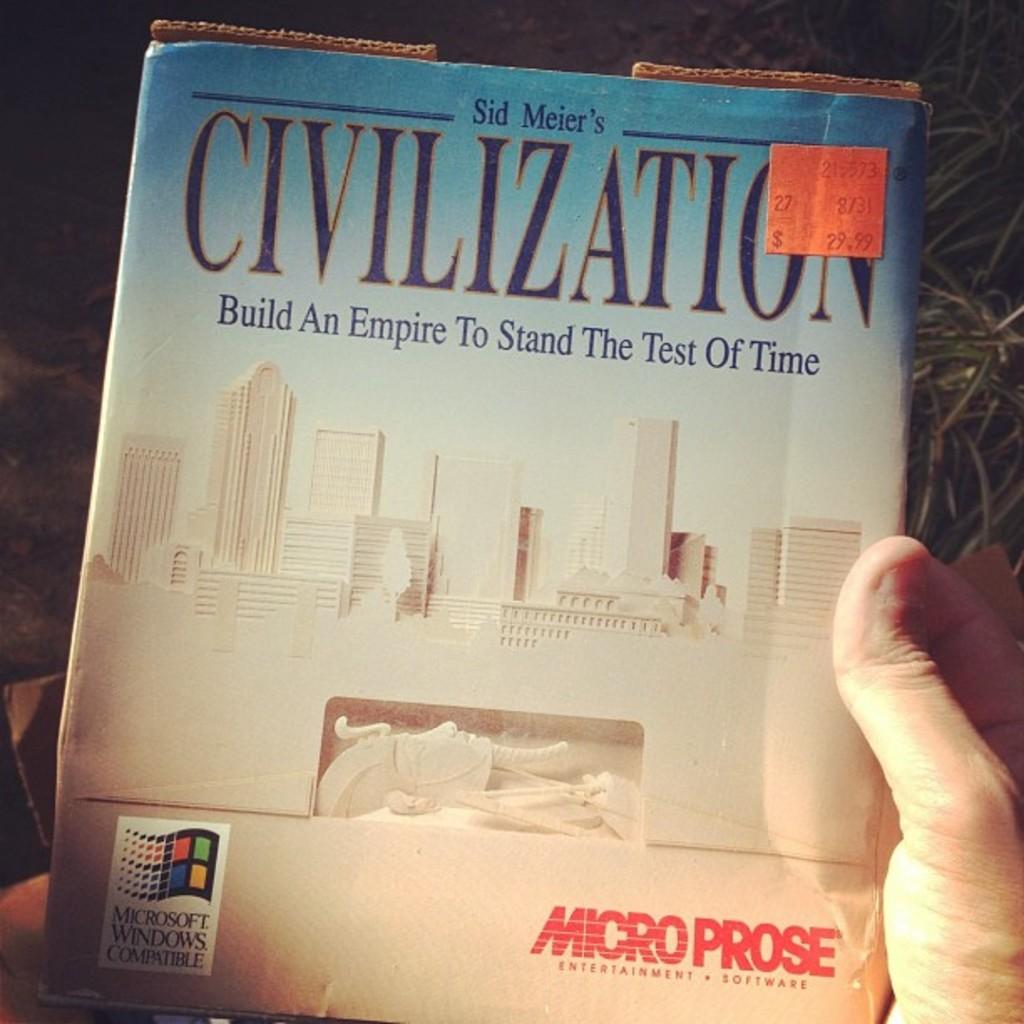What is the name on the top?
Your answer should be compact. Sid meier. 